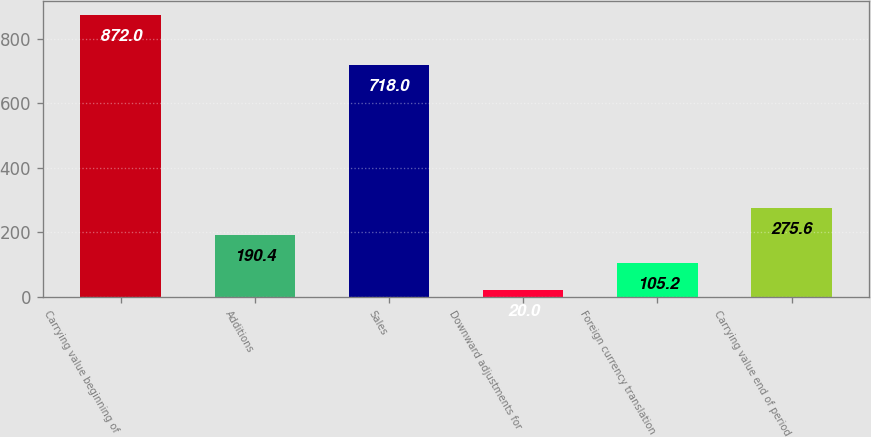Convert chart to OTSL. <chart><loc_0><loc_0><loc_500><loc_500><bar_chart><fcel>Carrying value beginning of<fcel>Additions<fcel>Sales<fcel>Downward adjustments for<fcel>Foreign currency translation<fcel>Carrying value end of period<nl><fcel>872<fcel>190.4<fcel>718<fcel>20<fcel>105.2<fcel>275.6<nl></chart> 